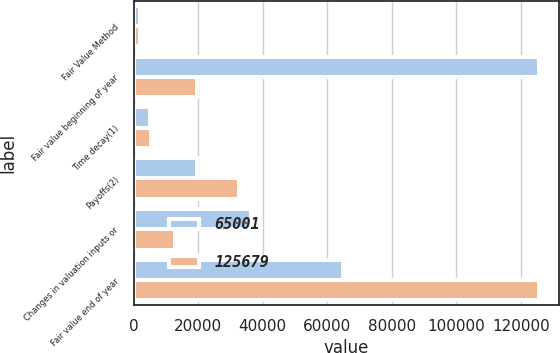Convert chart. <chart><loc_0><loc_0><loc_500><loc_500><stacked_bar_chart><ecel><fcel>Fair Value Method<fcel>Fair value beginning of year<fcel>Time decay(1)<fcel>Payoffs(2)<fcel>Changes in valuation inputs or<fcel>Fair value end of year<nl><fcel>65001<fcel>2011<fcel>125679<fcel>4966<fcel>19464<fcel>36248<fcel>65001<nl><fcel>125679<fcel>2010<fcel>19464<fcel>5359<fcel>32668<fcel>12721<fcel>125679<nl></chart> 